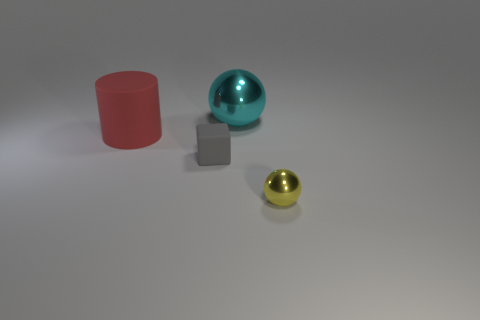There is a metallic sphere that is to the right of the big cyan metal ball; how big is it?
Your response must be concise. Small. What material is the big thing that is left of the shiny thing behind the metal thing that is right of the cyan metal ball?
Make the answer very short. Rubber. Is the small yellow thing the same shape as the gray rubber thing?
Keep it short and to the point. No. How many matte objects are large objects or big gray blocks?
Provide a succinct answer. 1. What number of small purple metal things are there?
Your answer should be compact. 0. What is the color of the shiny thing that is the same size as the red matte object?
Your answer should be compact. Cyan. Is the cube the same size as the cyan thing?
Your answer should be compact. No. Is the size of the cyan shiny object the same as the metallic sphere in front of the large rubber object?
Offer a very short reply. No. There is a thing that is on the left side of the yellow metallic sphere and in front of the red object; what is its color?
Offer a terse response. Gray. Is the number of cylinders that are in front of the big matte object greater than the number of yellow metallic balls behind the big shiny thing?
Offer a very short reply. No. 